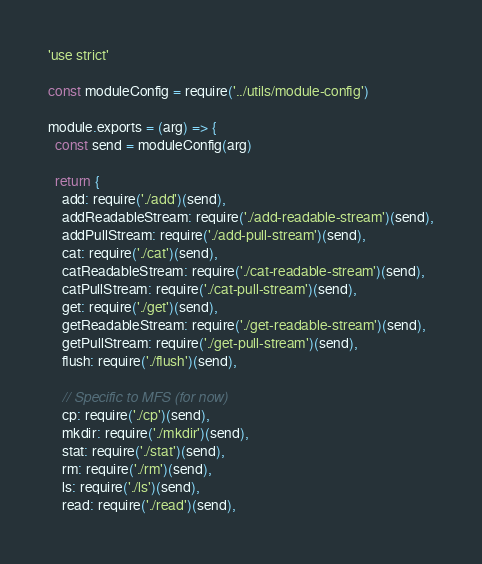<code> <loc_0><loc_0><loc_500><loc_500><_JavaScript_>'use strict'

const moduleConfig = require('../utils/module-config')

module.exports = (arg) => {
  const send = moduleConfig(arg)

  return {
    add: require('./add')(send),
    addReadableStream: require('./add-readable-stream')(send),
    addPullStream: require('./add-pull-stream')(send),
    cat: require('./cat')(send),
    catReadableStream: require('./cat-readable-stream')(send),
    catPullStream: require('./cat-pull-stream')(send),
    get: require('./get')(send),
    getReadableStream: require('./get-readable-stream')(send),
    getPullStream: require('./get-pull-stream')(send),
    flush: require('./flush')(send),

    // Specific to MFS (for now)
    cp: require('./cp')(send),
    mkdir: require('./mkdir')(send),
    stat: require('./stat')(send),
    rm: require('./rm')(send),
    ls: require('./ls')(send),
    read: require('./read')(send),</code> 